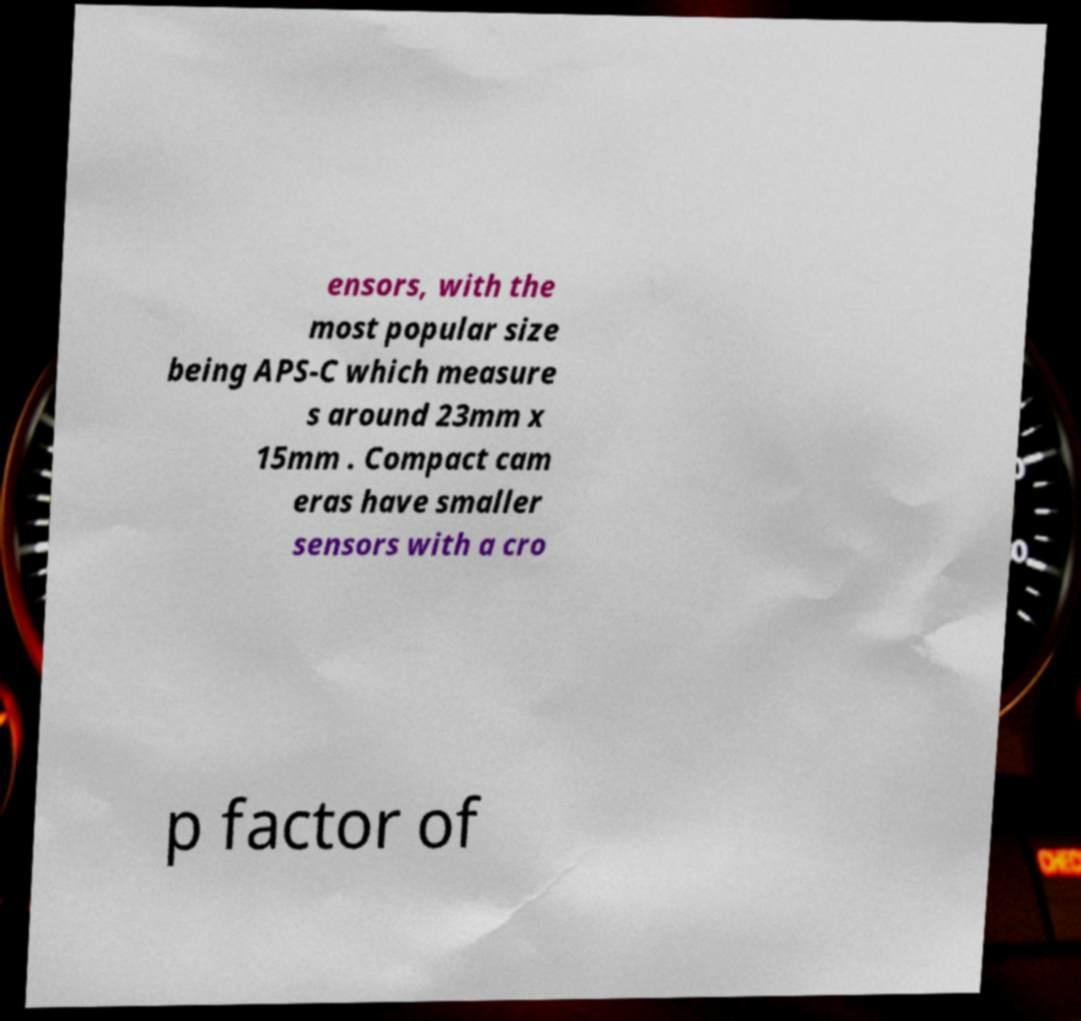Can you read and provide the text displayed in the image?This photo seems to have some interesting text. Can you extract and type it out for me? ensors, with the most popular size being APS-C which measure s around 23mm x 15mm . Compact cam eras have smaller sensors with a cro p factor of 